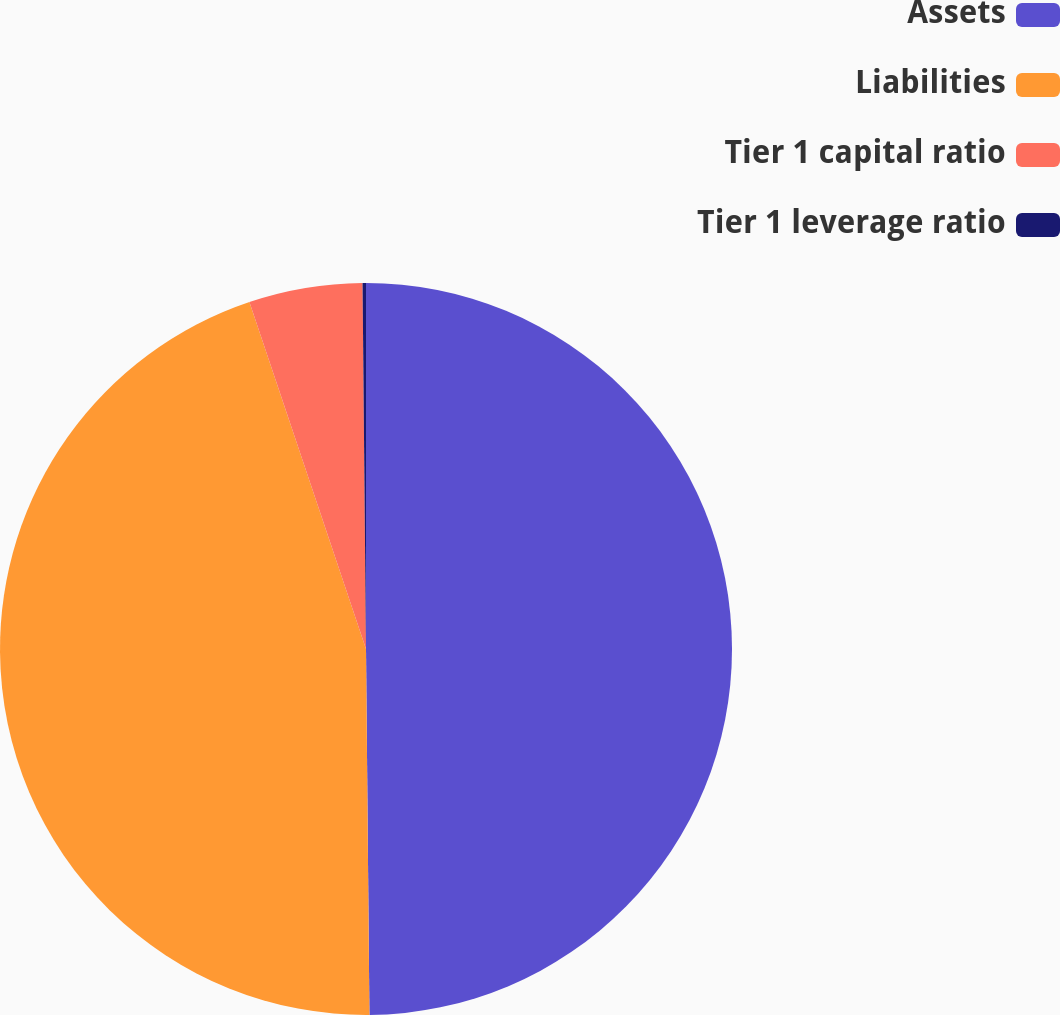<chart> <loc_0><loc_0><loc_500><loc_500><pie_chart><fcel>Assets<fcel>Liabilities<fcel>Tier 1 capital ratio<fcel>Tier 1 leverage ratio<nl><fcel>49.85%<fcel>44.99%<fcel>5.01%<fcel>0.15%<nl></chart> 